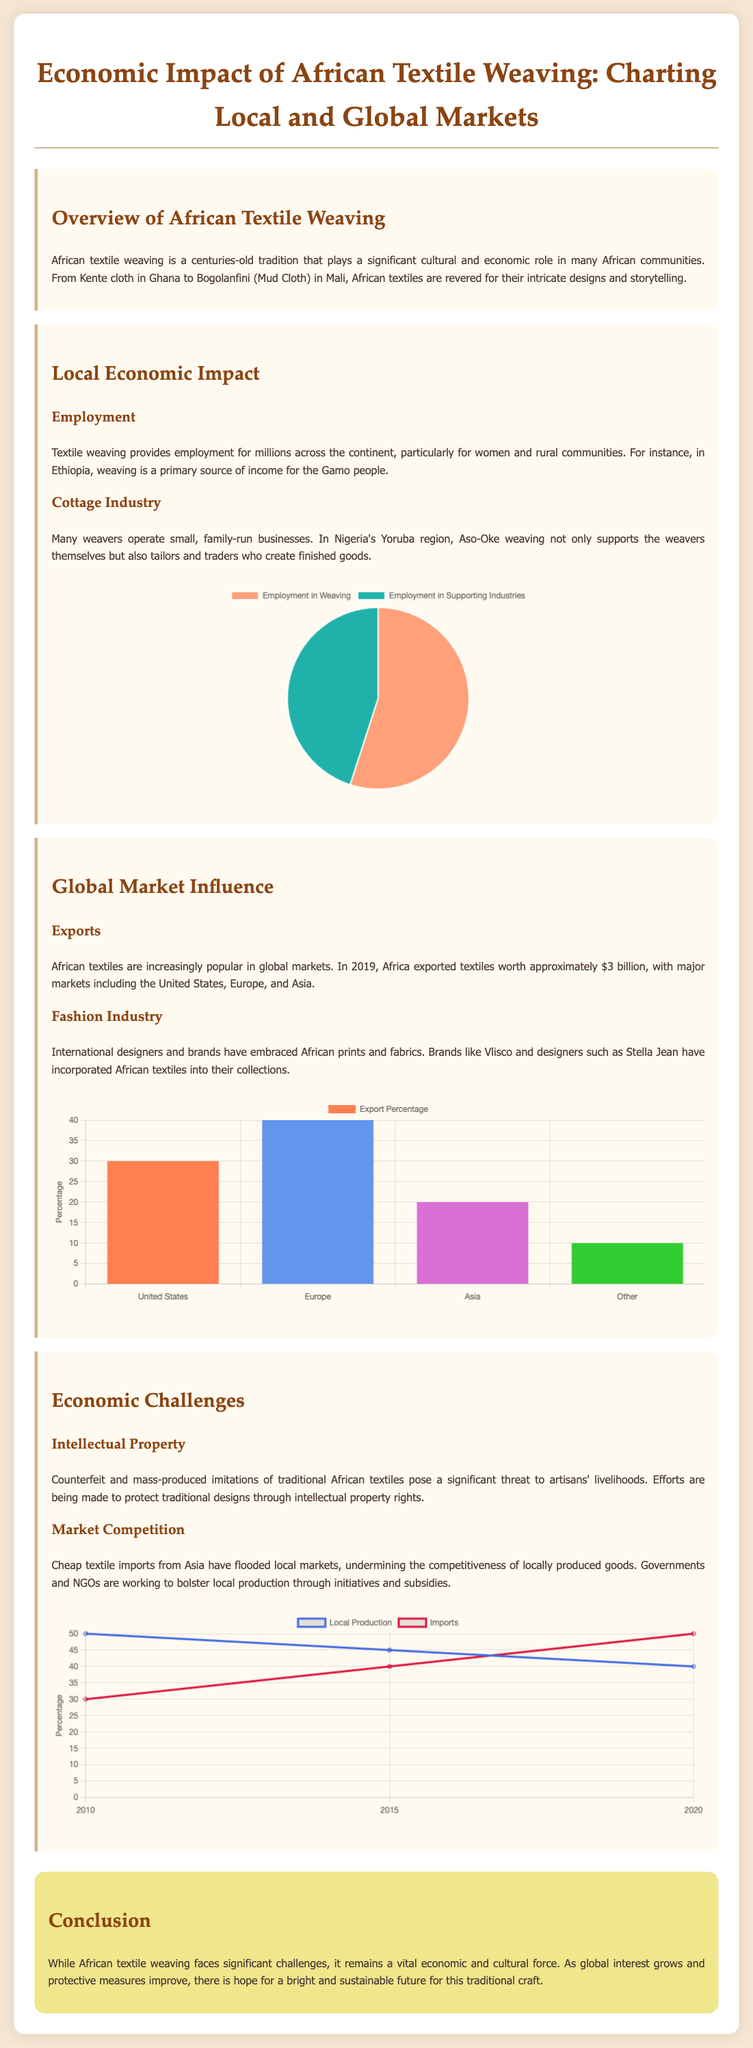What traditional cloth is mentioned as being significant in Ghana? Kente cloth is specifically highlighted as a significant traditional cloth from Ghana in the document.
Answer: Kente cloth What percentage of textile exports goes to Europe? The document states that 40 percent of textile exports are directed to Europe.
Answer: 40 In which year did Africa export textiles worth approximately $3 billion? The year given for the approximate $3 billion textile exports is 2019 according to the text.
Answer: 2019 What is the primary source of income for the Gamo people in Ethiopia? The document indicates that weaving is a primary source of income for the Gamo people.
Answer: Weaving What trend is shown regarding local production from 2010 to 2020? The chart illustrates a downward trend in local production over the years from 50 percent in 2010 to 40 percent in 2020.
Answer: Downward Which two types of economic impact are illustrated in the local impact chart? The local impact chart illustrates the distribution of employment between weaving and supporting industries.
Answer: Employment in Weaving, Employment in Supporting Industries What significant issue do counterfeit textiles pose according to the document? The document notes that counterfeit and mass-produced imitations significantly threaten artisans' livelihoods.
Answer: Livelihoods What is the title of the chart displaying local production versus imports trend? The title of the chart is indicated as "Local Production vs Imports Trend" in the document.
Answer: Local Production vs Imports Trend Which two countries are mentioned as major markets for African textile exports? The document names the United States and Europe as major markets for African textile exports.
Answer: United States, Europe 